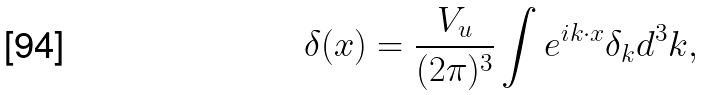Convert formula to latex. <formula><loc_0><loc_0><loc_500><loc_500>\delta ( { x } ) = \frac { V _ { u } } { ( 2 \pi ) ^ { 3 } } \int e ^ { i { k } \cdot { x } } \delta _ { k } d ^ { 3 } k ,</formula> 